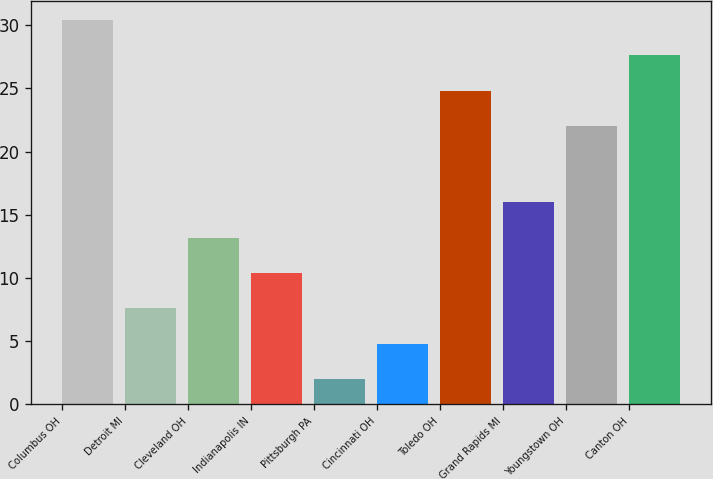Convert chart to OTSL. <chart><loc_0><loc_0><loc_500><loc_500><bar_chart><fcel>Columbus OH<fcel>Detroit MI<fcel>Cleveland OH<fcel>Indianapolis IN<fcel>Pittsburgh PA<fcel>Cincinnati OH<fcel>Toledo OH<fcel>Grand Rapids MI<fcel>Youngstown OH<fcel>Canton OH<nl><fcel>30.4<fcel>7.6<fcel>13.2<fcel>10.4<fcel>2<fcel>4.8<fcel>24.8<fcel>16<fcel>22<fcel>27.6<nl></chart> 